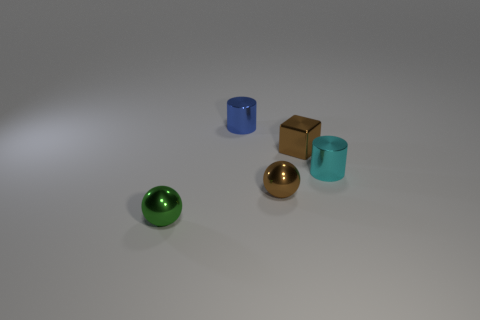Add 3 tiny gray rubber things. How many objects exist? 8 Subtract all blocks. How many objects are left? 4 Subtract 1 blue cylinders. How many objects are left? 4 Subtract all tiny brown objects. Subtract all blue things. How many objects are left? 2 Add 1 cyan metal cylinders. How many cyan metal cylinders are left? 2 Add 2 cyan objects. How many cyan objects exist? 3 